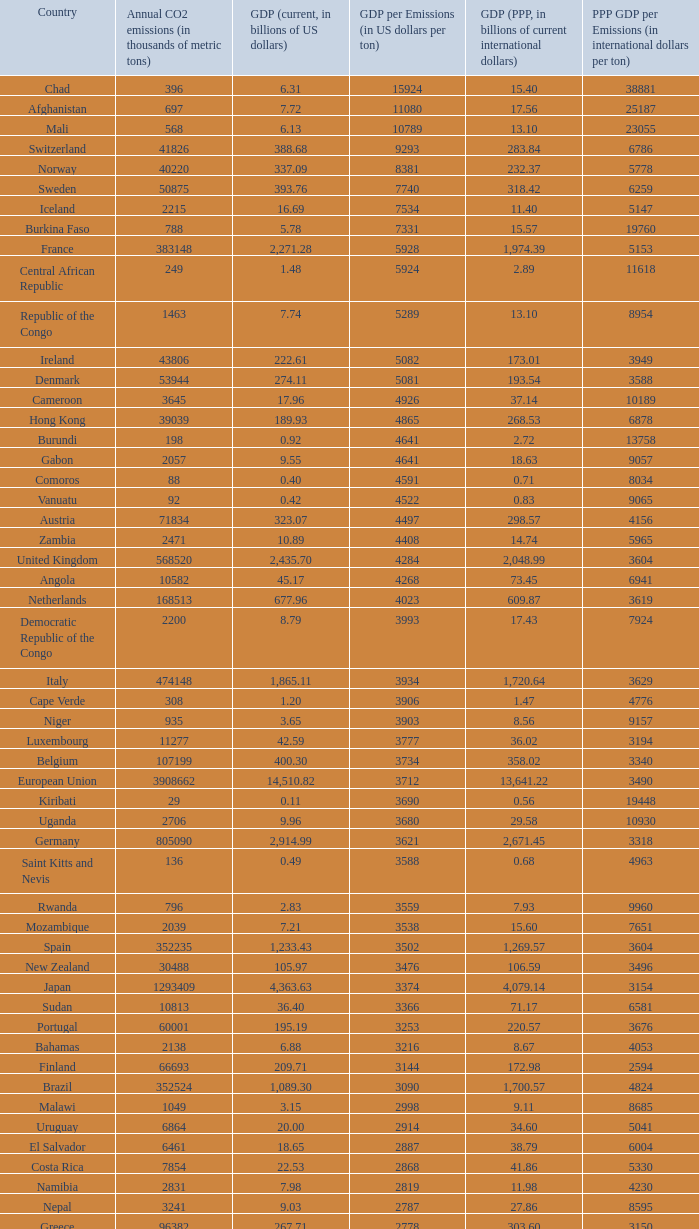Can you give me this table as a dict? {'header': ['Country', 'Annual CO2 emissions (in thousands of metric tons)', 'GDP (current, in billions of US dollars)', 'GDP per Emissions (in US dollars per ton)', 'GDP (PPP, in billions of current international dollars)', 'PPP GDP per Emissions (in international dollars per ton)'], 'rows': [['Chad', '396', '6.31', '15924', '15.40', '38881'], ['Afghanistan', '697', '7.72', '11080', '17.56', '25187'], ['Mali', '568', '6.13', '10789', '13.10', '23055'], ['Switzerland', '41826', '388.68', '9293', '283.84', '6786'], ['Norway', '40220', '337.09', '8381', '232.37', '5778'], ['Sweden', '50875', '393.76', '7740', '318.42', '6259'], ['Iceland', '2215', '16.69', '7534', '11.40', '5147'], ['Burkina Faso', '788', '5.78', '7331', '15.57', '19760'], ['France', '383148', '2,271.28', '5928', '1,974.39', '5153'], ['Central African Republic', '249', '1.48', '5924', '2.89', '11618'], ['Republic of the Congo', '1463', '7.74', '5289', '13.10', '8954'], ['Ireland', '43806', '222.61', '5082', '173.01', '3949'], ['Denmark', '53944', '274.11', '5081', '193.54', '3588'], ['Cameroon', '3645', '17.96', '4926', '37.14', '10189'], ['Hong Kong', '39039', '189.93', '4865', '268.53', '6878'], ['Burundi', '198', '0.92', '4641', '2.72', '13758'], ['Gabon', '2057', '9.55', '4641', '18.63', '9057'], ['Comoros', '88', '0.40', '4591', '0.71', '8034'], ['Vanuatu', '92', '0.42', '4522', '0.83', '9065'], ['Austria', '71834', '323.07', '4497', '298.57', '4156'], ['Zambia', '2471', '10.89', '4408', '14.74', '5965'], ['United Kingdom', '568520', '2,435.70', '4284', '2,048.99', '3604'], ['Angola', '10582', '45.17', '4268', '73.45', '6941'], ['Netherlands', '168513', '677.96', '4023', '609.87', '3619'], ['Democratic Republic of the Congo', '2200', '8.79', '3993', '17.43', '7924'], ['Italy', '474148', '1,865.11', '3934', '1,720.64', '3629'], ['Cape Verde', '308', '1.20', '3906', '1.47', '4776'], ['Niger', '935', '3.65', '3903', '8.56', '9157'], ['Luxembourg', '11277', '42.59', '3777', '36.02', '3194'], ['Belgium', '107199', '400.30', '3734', '358.02', '3340'], ['European Union', '3908662', '14,510.82', '3712', '13,641.22', '3490'], ['Kiribati', '29', '0.11', '3690', '0.56', '19448'], ['Uganda', '2706', '9.96', '3680', '29.58', '10930'], ['Germany', '805090', '2,914.99', '3621', '2,671.45', '3318'], ['Saint Kitts and Nevis', '136', '0.49', '3588', '0.68', '4963'], ['Rwanda', '796', '2.83', '3559', '7.93', '9960'], ['Mozambique', '2039', '7.21', '3538', '15.60', '7651'], ['Spain', '352235', '1,233.43', '3502', '1,269.57', '3604'], ['New Zealand', '30488', '105.97', '3476', '106.59', '3496'], ['Japan', '1293409', '4,363.63', '3374', '4,079.14', '3154'], ['Sudan', '10813', '36.40', '3366', '71.17', '6581'], ['Portugal', '60001', '195.19', '3253', '220.57', '3676'], ['Bahamas', '2138', '6.88', '3216', '8.67', '4053'], ['Finland', '66693', '209.71', '3144', '172.98', '2594'], ['Brazil', '352524', '1,089.30', '3090', '1,700.57', '4824'], ['Malawi', '1049', '3.15', '2998', '9.11', '8685'], ['Uruguay', '6864', '20.00', '2914', '34.60', '5041'], ['El Salvador', '6461', '18.65', '2887', '38.79', '6004'], ['Costa Rica', '7854', '22.53', '2868', '41.86', '5330'], ['Namibia', '2831', '7.98', '2819', '11.98', '4230'], ['Nepal', '3241', '9.03', '2787', '27.86', '8595'], ['Greece', '96382', '267.71', '2778', '303.60', '3150'], ['Samoa', '158', '0.43', '2747', '0.95', '5987'], ['Dominica', '117', '0.32', '2709', '0.66', '5632'], ['Latvia', '7462', '19.94', '2672', '35.22', '4720'], ['Tanzania', '5372', '14.35', '2671', '44.46', '8276'], ['Haiti', '1811', '4.84', '2670', '10.52', '5809'], ['Panama', '6428', '17.13', '2666', '30.21', '4700'], ['Swaziland', '1016', '2.67', '2629', '5.18', '5095'], ['Guatemala', '11766', '30.26', '2572', '57.77', '4910'], ['Slovenia', '15173', '38.94', '2566', '51.14', '3370'], ['Colombia', '63422', '162.50', '2562', '342.77', '5405'], ['Malta', '2548', '6.44', '2528', '8.88', '3485'], ['Ivory Coast', '6882', '17.38', '2526', '31.22', '4536'], ['Ethiopia', '6006', '15.17', '2525', '54.39', '9055'], ['Saint Lucia', '367', '0.93', '2520', '1.69', '4616'], ['Saint Vincent and the Grenadines', '198', '0.50', '2515', '0.96', '4843'], ['Singapore', '56217', '139.18', '2476', '208.75', '3713'], ['Laos', '1426', '3.51', '2459', '11.41', '8000'], ['Bhutan', '381', '0.93', '2444', '2.61', '6850'], ['Chile', '60100', '146.76', '2442', '214.41', '3568'], ['Peru', '38643', '92.31', '2389', '195.99', '5072'], ['Barbados', '1338', '3.19', '2385', '4.80', '3590'], ['Sri Lanka', '11876', '28.28', '2381', '77.51', '6526'], ['Botswana', '4770', '11.30', '2369', '23.51', '4929'], ['Antigua and Barbuda', '425', '1.01', '2367', '1.41', '3315'], ['Cyprus', '7788', '18.43', '2366', '19.99', '2566'], ['Canada', '544680', '1,278.97', '2348', '1,203.74', '2210'], ['Grenada', '242', '0.56', '2331', '1.05', '4331'], ['Paraguay', '3986', '9.28', '2327', '24.81', '6224'], ['United States', '5752289', '13,178.35', '2291', '13,178.35', '2291'], ['Equatorial Guinea', '4356', '9.60', '2205', '15.76', '3618'], ['Senegal', '4261', '9.37', '2198', '19.30', '4529'], ['Eritrea', '554', '1.21', '2186', '3.48', '6283'], ['Mexico', '436150', '952.34', '2184', '1,408.81', '3230'], ['Guinea', '1360', '2.90', '2135', '9.29', '6829'], ['Lithuania', '14190', '30.08', '2120', '54.04', '3808'], ['Albania', '4301', '9.11', '2119', '18.34', '4264'], ['Croatia', '23683', '49.04', '2071', '72.63', '3067'], ['Israel', '70440', '143.98', '2044', '174.61', '2479'], ['Australia', '372013', '755.21', '2030', '713.96', '1919'], ['South Korea', '475248', '952.03', '2003', '1,190.70', '2505'], ['Fiji', '1610', '3.17', '1967', '3.74', '2320'], ['Turkey', '269452', '529.19', '1964', '824.58', '3060'], ['Hungary', '57644', '113.05', '1961', '183.84', '3189'], ['Madagascar', '2834', '5.52', '1947', '16.84', '5943'], ['Brunei', '5911', '11.47', '1940', '18.93', '3203'], ['Timor-Leste', '176', '0.33', '1858', '1.96', '11153'], ['Solomon Islands', '180', '0.33', '1856', '0.86', '4789'], ['Kenya', '12151', '22.52', '1853', '52.74', '4340'], ['Togo', '1221', '2.22', '1818', '4.96', '4066'], ['Tonga', '132', '0.24', '1788', '0.54', '4076'], ['Cambodia', '4074', '7.26', '1783', '23.03', '5653'], ['Dominican Republic', '20357', '35.28', '1733', '63.94', '3141'], ['Philippines', '68328', '117.57', '1721', '272.25', '3984'], ['Bolivia', '6973', '11.53', '1653', '37.37', '5359'], ['Mauritius', '3850', '6.32', '1641', '13.09', '3399'], ['Mauritania', '1665', '2.70', '1621', '5.74', '3448'], ['Djibouti', '488', '0.77', '1576', '1.61', '3297'], ['Bangladesh', '41609', '65.20', '1567', '190.93', '4589'], ['Benin', '3109', '4.74', '1524', '11.29', '3631'], ['Gambia', '334', '0.51', '1521', '1.92', '5743'], ['Nigeria', '97262', '146.89', '1510', '268.21', '2758'], ['Honduras', '7194', '10.84', '1507', '28.20', '3920'], ['Slovakia', '37459', '56.00', '1495', '96.76', '2583'], ['Belize', '818', '1.21', '1483', '2.31', '2823'], ['Lebanon', '15330', '22.44', '1464', '40.46', '2639'], ['Armenia', '4371', '6.38', '1461', '14.68', '3357'], ['Morocco', '45316', '65.64', '1448', '120.32', '2655'], ['Burma', '10025', '14.50', '1447', '55.55', '5541'], ['Sierra Leone', '994', '1.42', '1433', '3.62', '3644'], ['Georgia', '5518', '7.77', '1408', '17.77', '3221'], ['Ghana', '9240', '12.73', '1378', '28.72', '3108'], ['Tunisia', '23126', '31.11', '1345', '70.57', '3052'], ['Ecuador', '31328', '41.40', '1322', '94.48', '3016'], ['Seychelles', '744', '0.97', '1301', '1.61', '2157'], ['Romania', '98490', '122.70', '1246', '226.51', '2300'], ['Qatar', '46193', '56.92', '1232', '66.90', '1448'], ['Argentina', '173536', '212.71', '1226', '469.75', '2707'], ['Czech Republic', '116991', '142.31', '1216', '228.48', '1953'], ['Nicaragua', '4334', '5.26', '1215', '14.93', '3444'], ['São Tomé and Príncipe', '103', '0.13', '1214', '0.24', '2311'], ['Papua New Guinea', '4620', '5.61', '1213', '10.91', '2361'], ['United Arab Emirates', '139553', '164.17', '1176', '154.35', '1106'], ['Kuwait', '86599', '101.56', '1173', '119.96', '1385'], ['Guinea-Bissau', '279', '0.32', '1136', '0.76', '2724'], ['Indonesia', '333483', '364.35', '1093', '767.92', '2303'], ['Venezuela', '171593', '184.25', '1074', '300.80', '1753'], ['Poland', '318219', '341.67', '1074', '567.94', '1785'], ['Maldives', '869', '0.92', '1053', '1.44', '1654'], ['Libya', '55495', '55.08', '992', '75.47', '1360'], ['Jamaica', '12151', '11.45', '942', '19.93', '1640'], ['Estonia', '17523', '16.45', '939', '25.31', '1444'], ['Saudi Arabia', '381564', '356.63', '935', '522.12', '1368'], ['Yemen', '21201', '19.06', '899', '49.21', '2321'], ['Pakistan', '142659', '127.49', '894', '372.96', '2614'], ['Algeria', '132715', '116.83', '880', '209.40', '1578'], ['Suriname', '2438', '2.14', '878', '3.76', '1543'], ['Oman', '41378', '35.73', '863', '56.44', '1364'], ['Malaysia', '187865', '156.86', '835', '328.97', '1751'], ['Liberia', '785', '0.61', '780', '1.19', '1520'], ['Thailand', '272521', '206.99', '760', '483.56', '1774'], ['Bahrain', '21292', '15.85', '744', '22.41', '1053'], ['Jordan', '20724', '14.84', '716', '26.25', '1266'], ['Bulgaria', '48085', '31.69', '659', '79.24', '1648'], ['Egypt', '166800', '107.38', '644', '367.64', '2204'], ['Russia', '1564669', '989.43', '632', '1,887.61', '1206'], ['South Africa', '414649', '257.89', '622', '433.51', '1045'], ['Serbia and Montenegro', '53266', '32.30', '606', '72.93', '1369'], ['Guyana', '1507', '0.91', '606', '2.70', '1792'], ['Azerbaijan', '35050', '21.03', '600', '51.71', '1475'], ['Macedonia', '10875', '6.38', '587', '16.14', '1484'], ['India', '1510351', '874.77', '579', '2,672.66', '1770'], ['Trinidad and Tobago', '33601', '19.38', '577', '23.62', '703'], ['Vietnam', '106132', '60.93', '574', '198.94', '1874'], ['Belarus', '68849', '36.96', '537', '94.80', '1377'], ['Iraq', '92572', '49.27', '532', '90.51', '978'], ['Kyrgyzstan', '5566', '2.84', '510', '9.45', '1698'], ['Zimbabwe', '11081', '5.60', '505', '2.29', '207'], ['Syria', '68460', '33.51', '489', '82.09', '1199'], ['Turkmenistan', '44103', '21.40', '485', '23.40', '531'], ['Iran', '466976', '222.13', '476', '693.32', '1485'], ['Bosnia and Herzegovina', '27438', '12.28', '447', '25.70', '937'], ['Tajikistan', '6391', '2.81', '440', '10.69', '1672'], ['Moldova', '7821', '3.41', '436', '9.19', '1175'], ['China', '6103493', '2,657.84', '435', '6,122.24', '1003'], ['Kazakhstan', '193508', '81.00', '419', '150.56', '778'], ['Ukraine', '319158', '108.00', '338', '291.30', '913'], ['Mongolia', '9442', '3.16', '334', '7.47', '791']]} Which country has an annual co2 emission of 1,811 thousand metric tons? Haiti. 